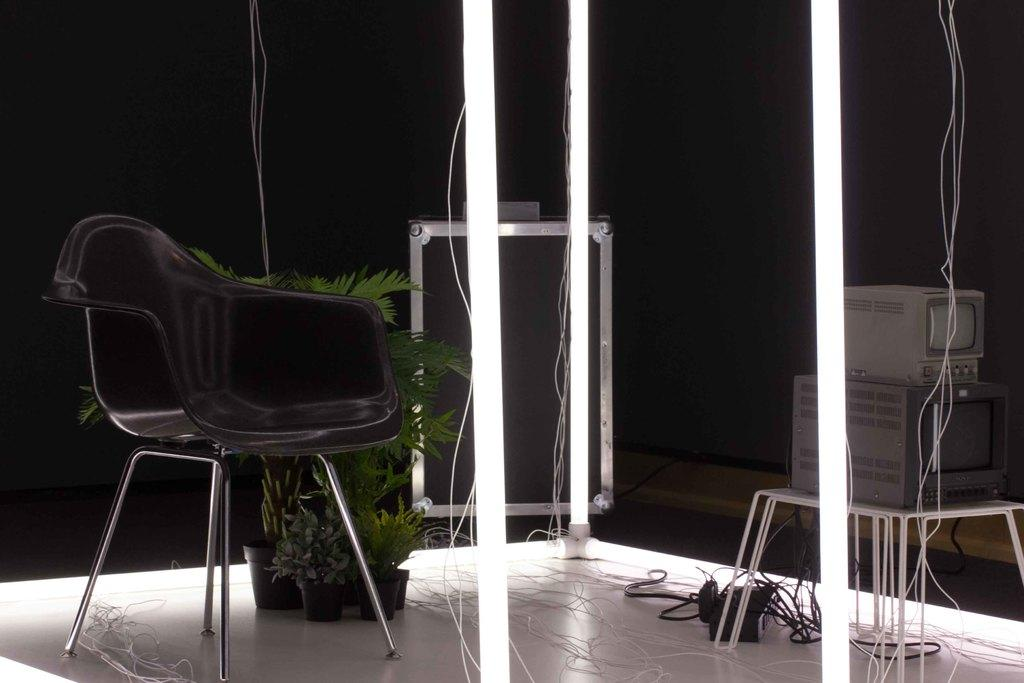What type of furniture is present in the image? There is a chair in the image. What color is the chair? The chair is black in color. What else can be seen in the image besides the chair? There are plants in the image. How does the chair express disgust in the image? The chair does not express any emotions, including disgust, as it is an inanimate object. 